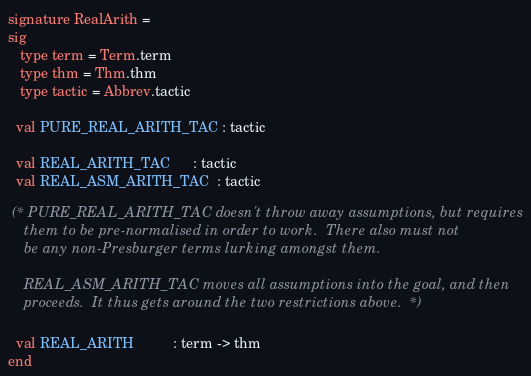Convert code to text. <code><loc_0><loc_0><loc_500><loc_500><_SML_>signature RealArith =
sig
   type term = Term.term
   type thm = Thm.thm
   type tactic = Abbrev.tactic

  val PURE_REAL_ARITH_TAC : tactic

  val REAL_ARITH_TAC      : tactic
  val REAL_ASM_ARITH_TAC  : tactic

 (* PURE_REAL_ARITH_TAC doesn't throw away assumptions, but requires
    them to be pre-normalised in order to work.  There also must not
    be any non-Presburger terms lurking amongst them.

    REAL_ASM_ARITH_TAC moves all assumptions into the goal, and then
    proceeds.  It thus gets around the two restrictions above.  *)

  val REAL_ARITH          : term -> thm
end
</code> 